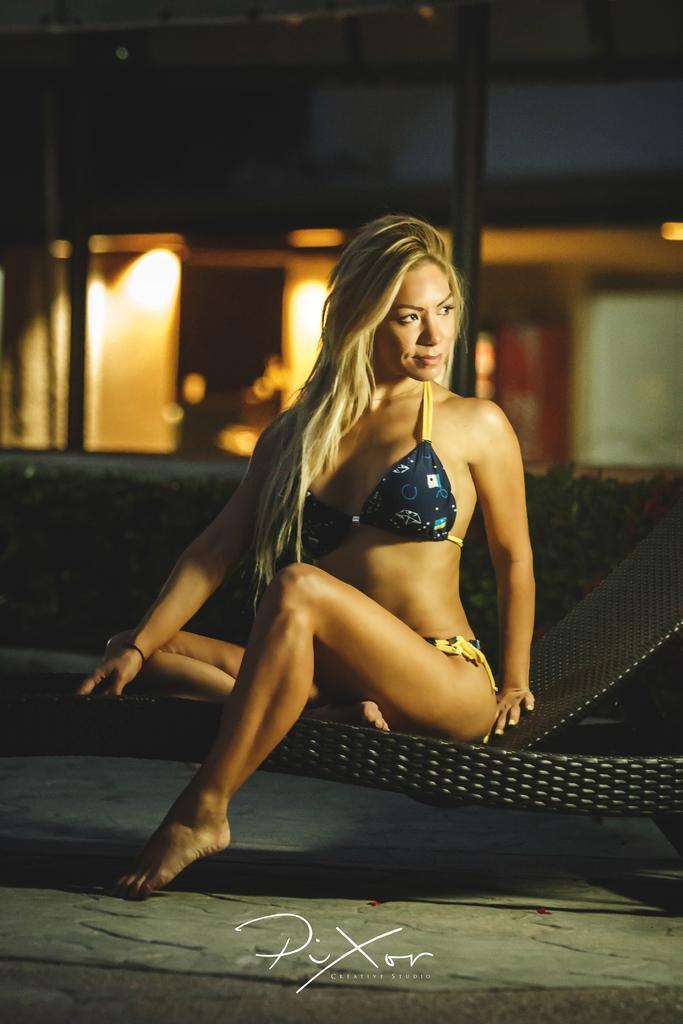Can you describe this image briefly? In this image we can see a woman is sitting, she is wearing the bikini. 